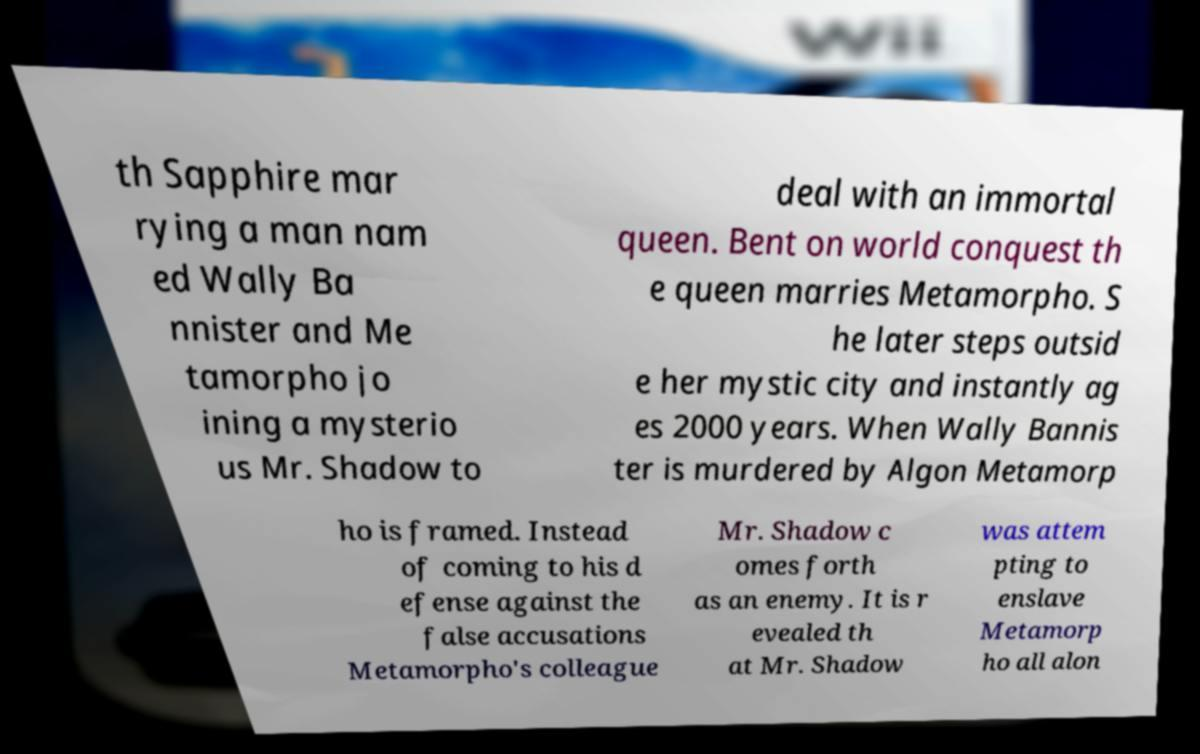For documentation purposes, I need the text within this image transcribed. Could you provide that? th Sapphire mar rying a man nam ed Wally Ba nnister and Me tamorpho jo ining a mysterio us Mr. Shadow to deal with an immortal queen. Bent on world conquest th e queen marries Metamorpho. S he later steps outsid e her mystic city and instantly ag es 2000 years. When Wally Bannis ter is murdered by Algon Metamorp ho is framed. Instead of coming to his d efense against the false accusations Metamorpho's colleague Mr. Shadow c omes forth as an enemy. It is r evealed th at Mr. Shadow was attem pting to enslave Metamorp ho all alon 